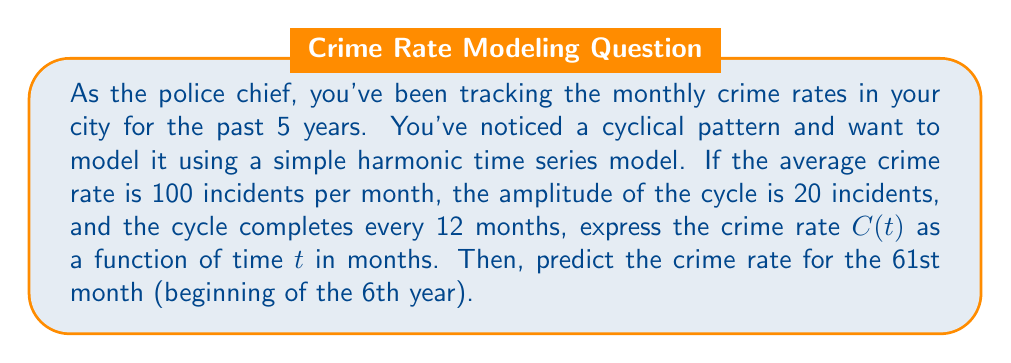Help me with this question. 1) The general form of a simple harmonic time series model is:

   $$C(t) = a + b \cos(\omega t) + c \sin(\omega t)$$

   where $a$ is the mean, $b$ and $c$ determine the amplitude, and $\omega$ is the angular frequency.

2) Given:
   - Mean crime rate $a = 100$
   - Amplitude $A = 20$
   - Period $T = 12$ months

3) The angular frequency $\omega$ is calculated as:
   $$\omega = \frac{2\pi}{T} = \frac{2\pi}{12} = \frac{\pi}{6}$$

4) For simplicity, we can assume the cycle starts at its peak, so we can use a cosine function with $b = A = 20$ and $c = 0$:

   $$C(t) = 100 + 20 \cos(\frac{\pi}{6}t)$$

5) To predict the crime rate for the 61st month, substitute $t = 61$:

   $$C(61) = 100 + 20 \cos(\frac{\pi}{6} \cdot 61)$$
   $$= 100 + 20 \cos(\frac{61\pi}{6})$$
   $$= 100 + 20 \cos(10\pi + \frac{\pi}{6})$$
   $$= 100 + 20 \cos(\frac{\pi}{6})$$
   $$\approx 100 + 20 \cdot 0.866$$
   $$\approx 117.32$$

6) Therefore, the predicted crime rate for the 61st month is approximately 117 incidents.
Answer: $C(t) = 100 + 20 \cos(\frac{\pi}{6}t)$; 117 incidents 